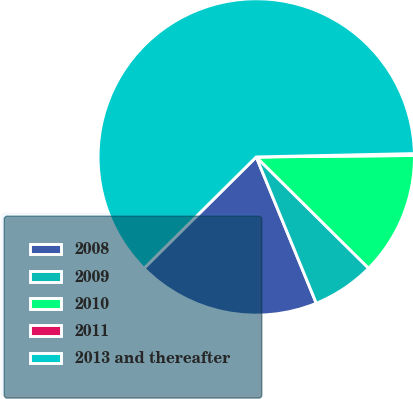Convert chart. <chart><loc_0><loc_0><loc_500><loc_500><pie_chart><fcel>2008<fcel>2009<fcel>2010<fcel>2011<fcel>2013 and thereafter<nl><fcel>18.76%<fcel>6.38%<fcel>12.57%<fcel>0.19%<fcel>62.09%<nl></chart> 